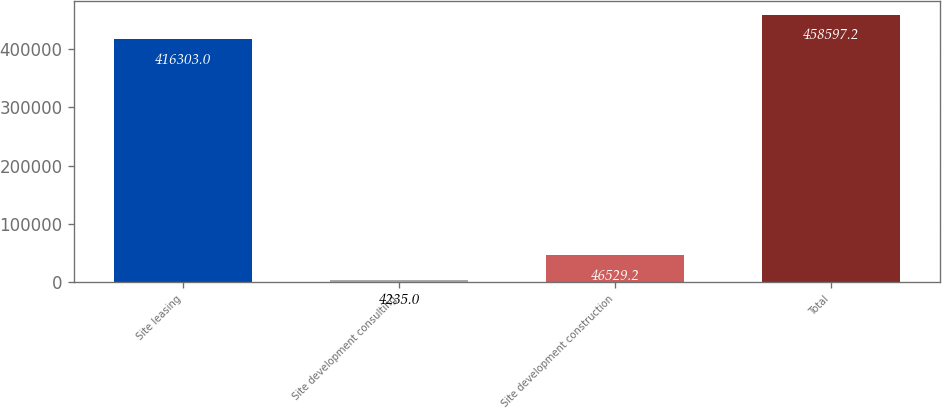Convert chart to OTSL. <chart><loc_0><loc_0><loc_500><loc_500><bar_chart><fcel>Site leasing<fcel>Site development consulting<fcel>Site development construction<fcel>Total<nl><fcel>416303<fcel>4235<fcel>46529.2<fcel>458597<nl></chart> 